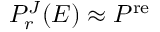Convert formula to latex. <formula><loc_0><loc_0><loc_500><loc_500>P _ { r } ^ { J } ( E ) \approx P ^ { r e }</formula> 